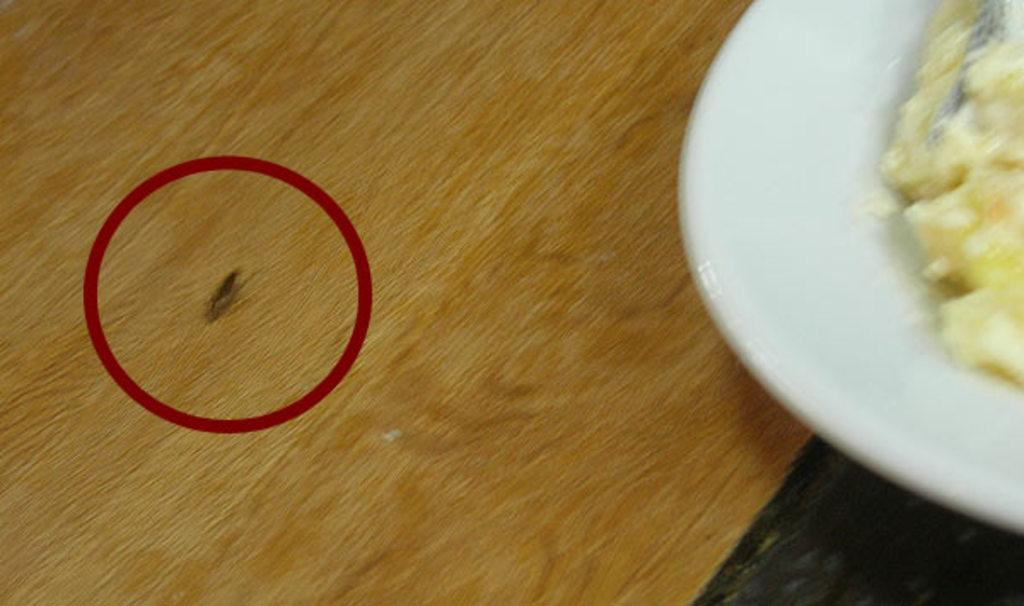What type of creature can be seen in the image? There is an insect in the image. Where is the insect located? The insect is on a wooden object. What else can be seen in the image besides the insect? There is a plate in the image. What is on the plate? There is a food item on the plate. What role does the father play in the image? There is no reference to a father or any people in the image, so it is not possible to determine any roles. 